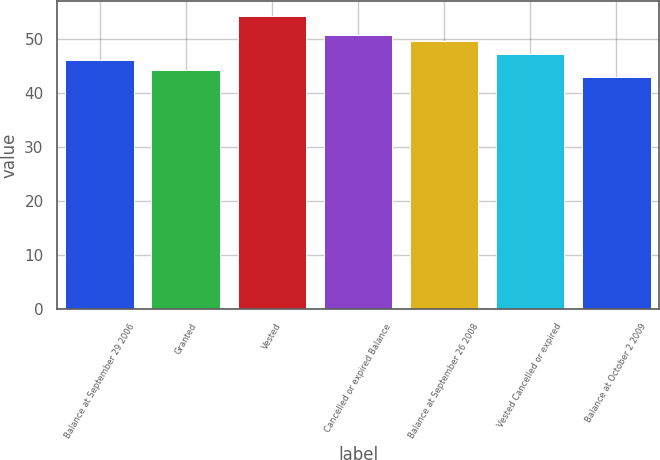Convert chart. <chart><loc_0><loc_0><loc_500><loc_500><bar_chart><fcel>Balance at September 29 2006<fcel>Granted<fcel>Vested<fcel>Cancelled or expired Balance<fcel>Balance at September 26 2008<fcel>Vested Cancelled or expired<fcel>Balance at October 2 2009<nl><fcel>46.05<fcel>44.19<fcel>54.19<fcel>50.75<fcel>49.62<fcel>47.27<fcel>42.89<nl></chart> 